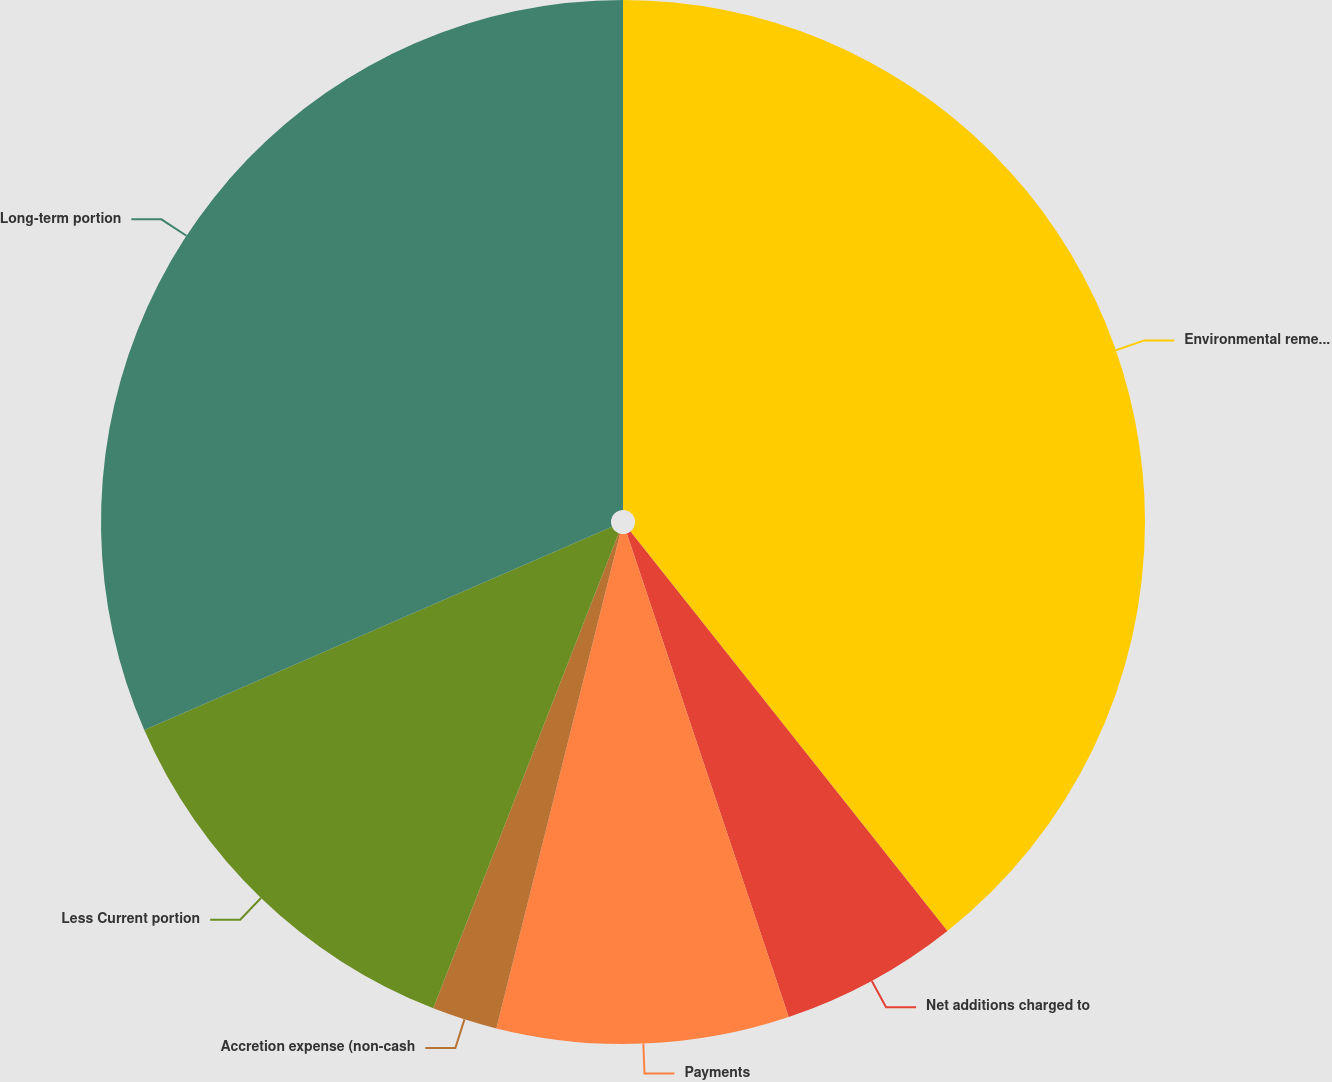<chart> <loc_0><loc_0><loc_500><loc_500><pie_chart><fcel>Environmental remediation<fcel>Net additions charged to<fcel>Payments<fcel>Accretion expense (non-cash<fcel>Less Current portion<fcel>Long-term portion<nl><fcel>39.32%<fcel>5.53%<fcel>9.04%<fcel>2.02%<fcel>12.55%<fcel>31.52%<nl></chart> 